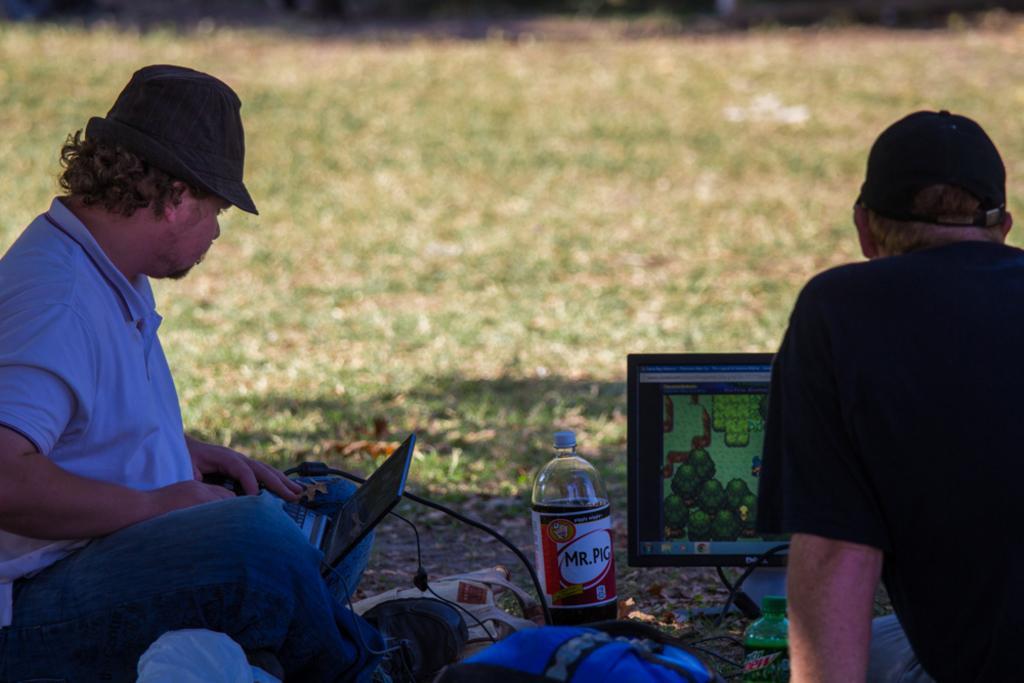How would you summarize this image in a sentence or two? There are two persons sitting on the ground ,here there is bottle and the laptop. 